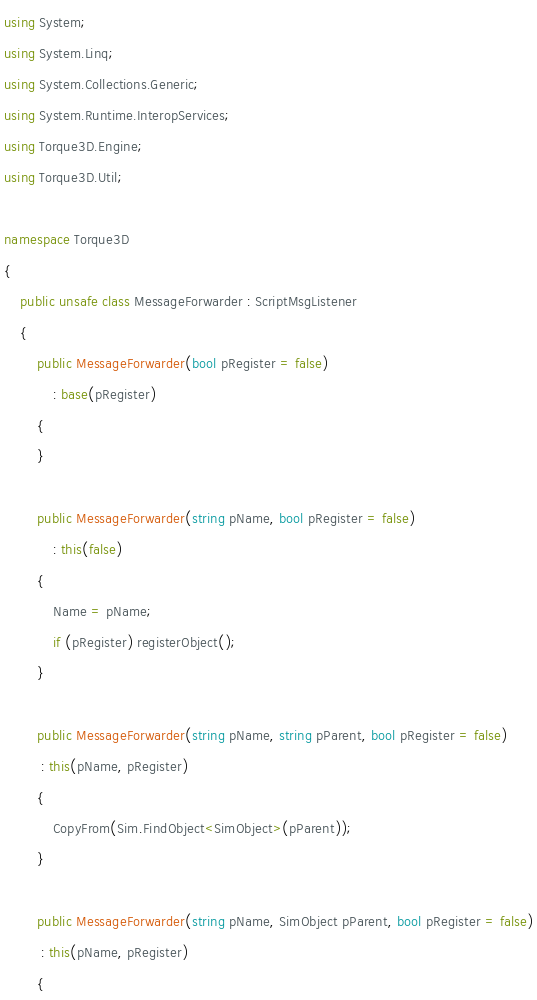Convert code to text. <code><loc_0><loc_0><loc_500><loc_500><_C#_>using System;
using System.Linq;
using System.Collections.Generic;
using System.Runtime.InteropServices;
using Torque3D.Engine;
using Torque3D.Util;

namespace Torque3D
{
	public unsafe class MessageForwarder : ScriptMsgListener
	{
		public MessageForwarder(bool pRegister = false)
			: base(pRegister)
		{
		}

		public MessageForwarder(string pName, bool pRegister = false)
			: this(false)
		{
			Name = pName;
			if (pRegister) registerObject();
		}

		public MessageForwarder(string pName, string pParent, bool pRegister = false)
         : this(pName, pRegister)
		{
			CopyFrom(Sim.FindObject<SimObject>(pParent));
		}

		public MessageForwarder(string pName, SimObject pParent, bool pRegister = false)
         : this(pName, pRegister)
		{</code> 